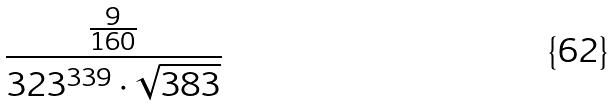<formula> <loc_0><loc_0><loc_500><loc_500>\frac { \frac { 9 } { 1 6 0 } } { 3 2 3 ^ { 3 3 9 } \cdot \sqrt { 3 8 3 } }</formula> 